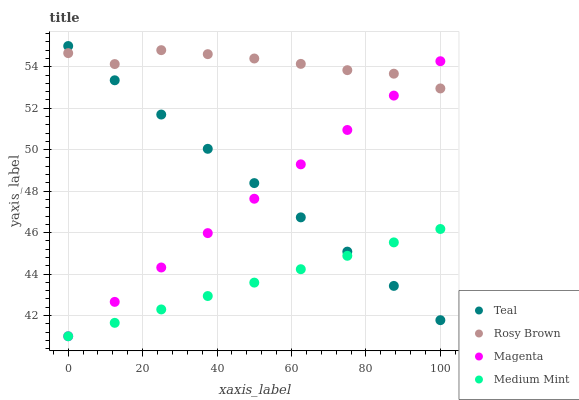Does Medium Mint have the minimum area under the curve?
Answer yes or no. Yes. Does Rosy Brown have the maximum area under the curve?
Answer yes or no. Yes. Does Magenta have the minimum area under the curve?
Answer yes or no. No. Does Magenta have the maximum area under the curve?
Answer yes or no. No. Is Magenta the smoothest?
Answer yes or no. Yes. Is Rosy Brown the roughest?
Answer yes or no. Yes. Is Rosy Brown the smoothest?
Answer yes or no. No. Is Magenta the roughest?
Answer yes or no. No. Does Medium Mint have the lowest value?
Answer yes or no. Yes. Does Rosy Brown have the lowest value?
Answer yes or no. No. Does Teal have the highest value?
Answer yes or no. Yes. Does Magenta have the highest value?
Answer yes or no. No. Is Medium Mint less than Rosy Brown?
Answer yes or no. Yes. Is Rosy Brown greater than Medium Mint?
Answer yes or no. Yes. Does Medium Mint intersect Teal?
Answer yes or no. Yes. Is Medium Mint less than Teal?
Answer yes or no. No. Is Medium Mint greater than Teal?
Answer yes or no. No. Does Medium Mint intersect Rosy Brown?
Answer yes or no. No. 